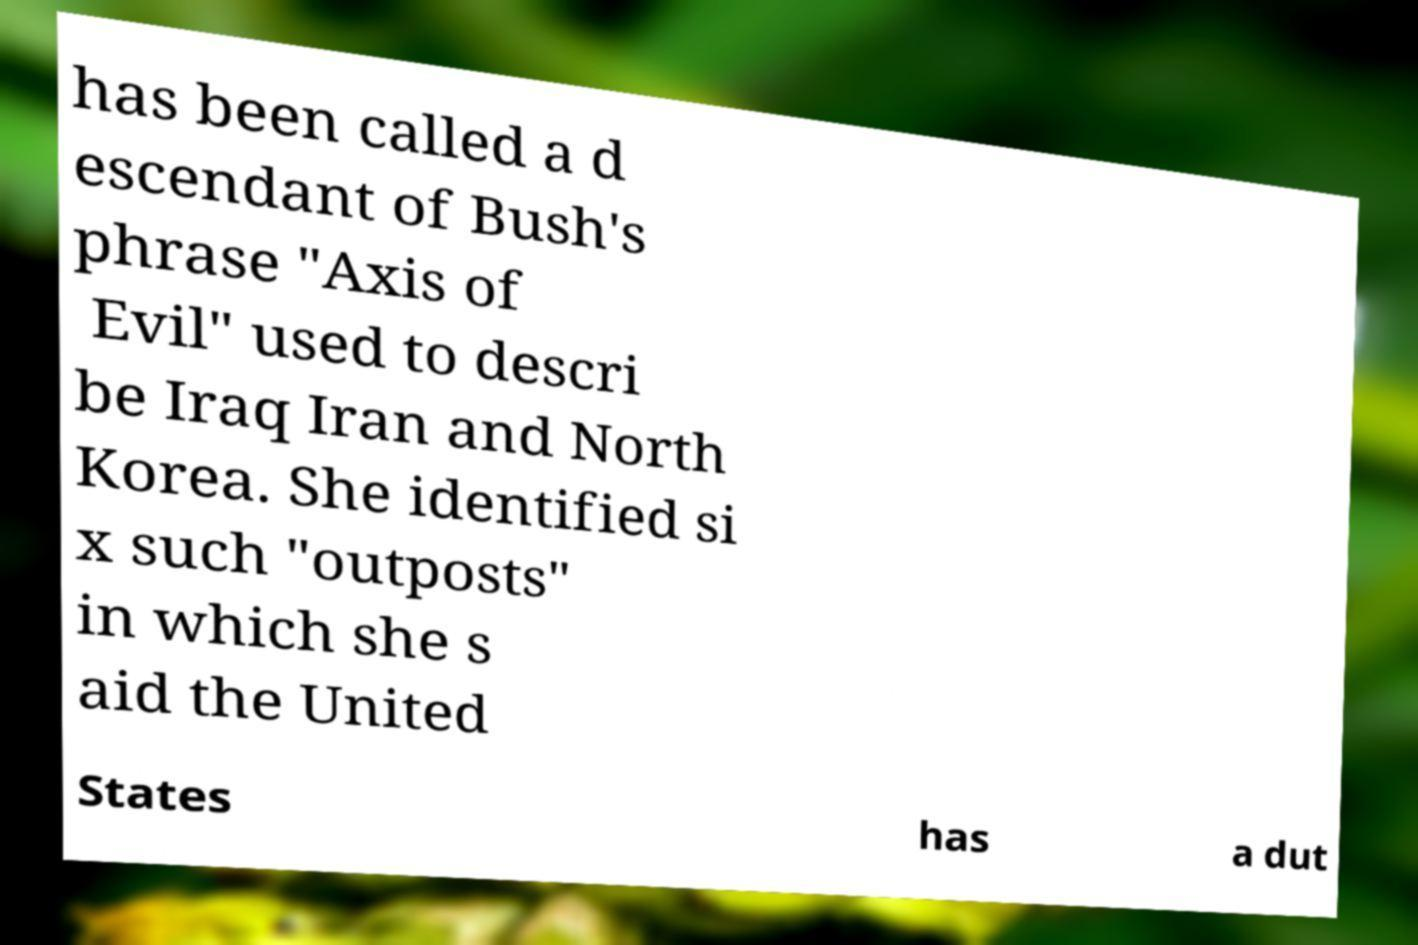There's text embedded in this image that I need extracted. Can you transcribe it verbatim? has been called a d escendant of Bush's phrase "Axis of Evil" used to descri be Iraq Iran and North Korea. She identified si x such "outposts" in which she s aid the United States has a dut 